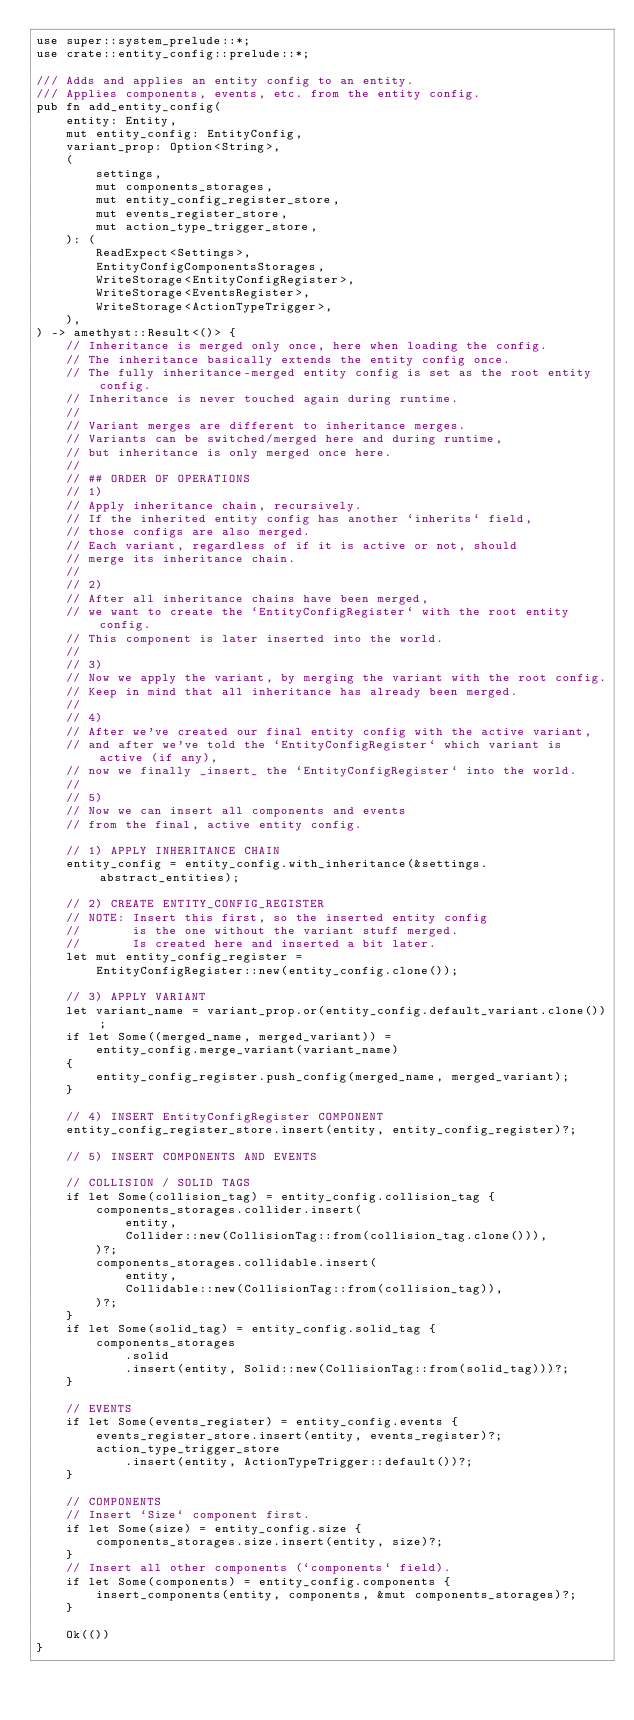Convert code to text. <code><loc_0><loc_0><loc_500><loc_500><_Rust_>use super::system_prelude::*;
use crate::entity_config::prelude::*;

/// Adds and applies an entity config to an entity.
/// Applies components, events, etc. from the entity config.
pub fn add_entity_config(
    entity: Entity,
    mut entity_config: EntityConfig,
    variant_prop: Option<String>,
    (
        settings,
        mut components_storages,
        mut entity_config_register_store,
        mut events_register_store,
        mut action_type_trigger_store,
    ): (
        ReadExpect<Settings>,
        EntityConfigComponentsStorages,
        WriteStorage<EntityConfigRegister>,
        WriteStorage<EventsRegister>,
        WriteStorage<ActionTypeTrigger>,
    ),
) -> amethyst::Result<()> {
    // Inheritance is merged only once, here when loading the config.
    // The inheritance basically extends the entity config once.
    // The fully inheritance-merged entity config is set as the root entity config.
    // Inheritance is never touched again during runtime.
    //
    // Variant merges are different to inheritance merges.
    // Variants can be switched/merged here and during runtime,
    // but inheritance is only merged once here.
    //
    // ## ORDER OF OPERATIONS
    // 1)
    // Apply inheritance chain, recursively.
    // If the inherited entity config has another `inherits` field,
    // those configs are also merged.
    // Each variant, regardless of if it is active or not, should
    // merge its inheritance chain.
    //
    // 2)
    // After all inheritance chains have been merged,
    // we want to create the `EntityConfigRegister` with the root entity config.
    // This component is later inserted into the world.
    //
    // 3)
    // Now we apply the variant, by merging the variant with the root config.
    // Keep in mind that all inheritance has already been merged.
    //
    // 4)
    // After we've created our final entity config with the active variant,
    // and after we've told the `EntityConfigRegister` which variant is active (if any),
    // now we finally _insert_ the `EntityConfigRegister` into the world.
    //
    // 5)
    // Now we can insert all components and events
    // from the final, active entity config.

    // 1) APPLY INHERITANCE CHAIN
    entity_config = entity_config.with_inheritance(&settings.abstract_entities);

    // 2) CREATE ENTITY_CONFIG_REGISTER
    // NOTE: Insert this first, so the inserted entity config
    //       is the one without the variant stuff merged.
    //       Is created here and inserted a bit later.
    let mut entity_config_register =
        EntityConfigRegister::new(entity_config.clone());

    // 3) APPLY VARIANT
    let variant_name = variant_prop.or(entity_config.default_variant.clone());
    if let Some((merged_name, merged_variant)) =
        entity_config.merge_variant(variant_name)
    {
        entity_config_register.push_config(merged_name, merged_variant);
    }

    // 4) INSERT EntityConfigRegister COMPONENT
    entity_config_register_store.insert(entity, entity_config_register)?;

    // 5) INSERT COMPONENTS AND EVENTS

    // COLLISION / SOLID TAGS
    if let Some(collision_tag) = entity_config.collision_tag {
        components_storages.collider.insert(
            entity,
            Collider::new(CollisionTag::from(collision_tag.clone())),
        )?;
        components_storages.collidable.insert(
            entity,
            Collidable::new(CollisionTag::from(collision_tag)),
        )?;
    }
    if let Some(solid_tag) = entity_config.solid_tag {
        components_storages
            .solid
            .insert(entity, Solid::new(CollisionTag::from(solid_tag)))?;
    }

    // EVENTS
    if let Some(events_register) = entity_config.events {
        events_register_store.insert(entity, events_register)?;
        action_type_trigger_store
            .insert(entity, ActionTypeTrigger::default())?;
    }

    // COMPONENTS
    // Insert `Size` component first.
    if let Some(size) = entity_config.size {
        components_storages.size.insert(entity, size)?;
    }
    // Insert all other components (`components` field).
    if let Some(components) = entity_config.components {
        insert_components(entity, components, &mut components_storages)?;
    }

    Ok(())
}
</code> 